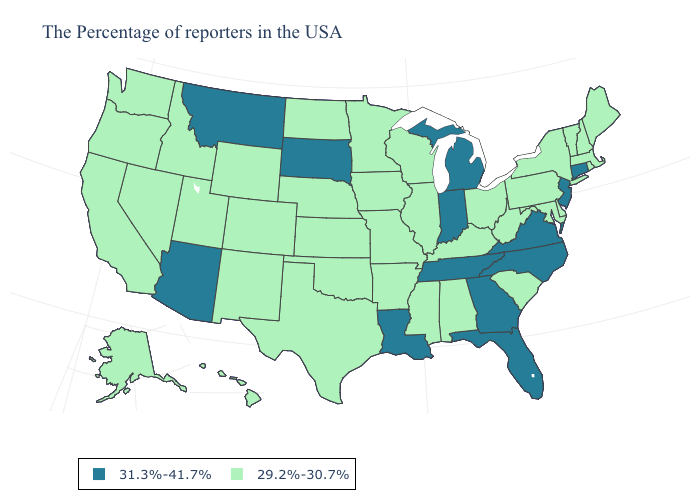Which states have the highest value in the USA?
Be succinct. Connecticut, New Jersey, Virginia, North Carolina, Florida, Georgia, Michigan, Indiana, Tennessee, Louisiana, South Dakota, Montana, Arizona. What is the value of California?
Write a very short answer. 29.2%-30.7%. What is the value of Illinois?
Give a very brief answer. 29.2%-30.7%. Name the states that have a value in the range 29.2%-30.7%?
Answer briefly. Maine, Massachusetts, Rhode Island, New Hampshire, Vermont, New York, Delaware, Maryland, Pennsylvania, South Carolina, West Virginia, Ohio, Kentucky, Alabama, Wisconsin, Illinois, Mississippi, Missouri, Arkansas, Minnesota, Iowa, Kansas, Nebraska, Oklahoma, Texas, North Dakota, Wyoming, Colorado, New Mexico, Utah, Idaho, Nevada, California, Washington, Oregon, Alaska, Hawaii. Does Massachusetts have the lowest value in the Northeast?
Answer briefly. Yes. What is the lowest value in the USA?
Short answer required. 29.2%-30.7%. What is the highest value in states that border Idaho?
Keep it brief. 31.3%-41.7%. Which states have the lowest value in the USA?
Be succinct. Maine, Massachusetts, Rhode Island, New Hampshire, Vermont, New York, Delaware, Maryland, Pennsylvania, South Carolina, West Virginia, Ohio, Kentucky, Alabama, Wisconsin, Illinois, Mississippi, Missouri, Arkansas, Minnesota, Iowa, Kansas, Nebraska, Oklahoma, Texas, North Dakota, Wyoming, Colorado, New Mexico, Utah, Idaho, Nevada, California, Washington, Oregon, Alaska, Hawaii. What is the lowest value in states that border Colorado?
Give a very brief answer. 29.2%-30.7%. Name the states that have a value in the range 31.3%-41.7%?
Short answer required. Connecticut, New Jersey, Virginia, North Carolina, Florida, Georgia, Michigan, Indiana, Tennessee, Louisiana, South Dakota, Montana, Arizona. Is the legend a continuous bar?
Quick response, please. No. Which states hav the highest value in the West?
Give a very brief answer. Montana, Arizona. What is the value of New Jersey?
Write a very short answer. 31.3%-41.7%. Which states have the highest value in the USA?
Be succinct. Connecticut, New Jersey, Virginia, North Carolina, Florida, Georgia, Michigan, Indiana, Tennessee, Louisiana, South Dakota, Montana, Arizona. 